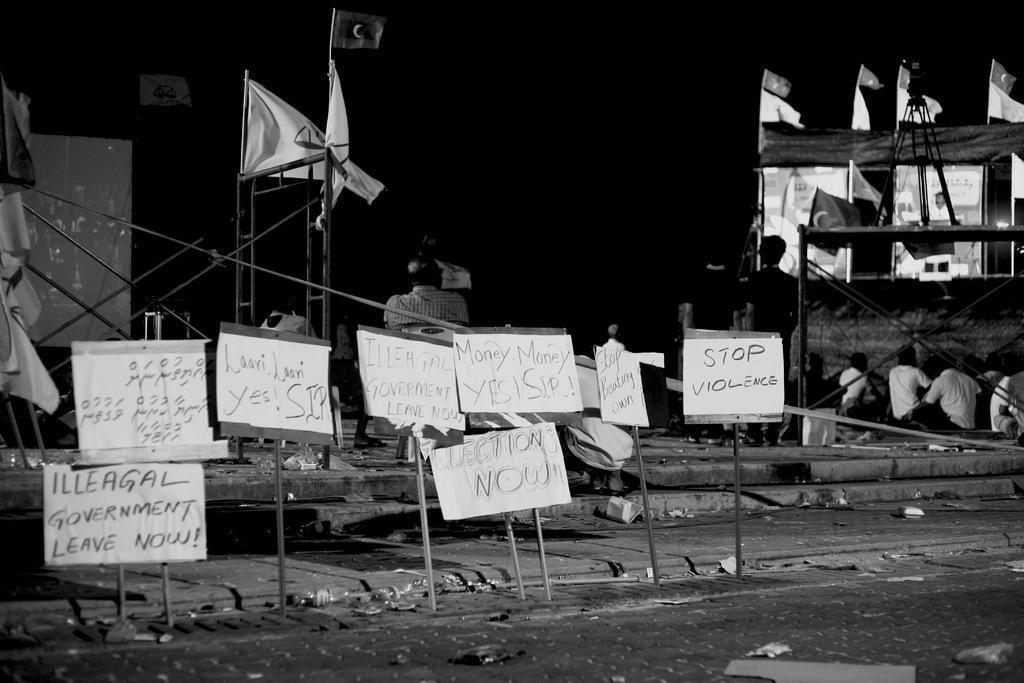Please provide a concise description of this image. In this image in the center there are boards with some text written on it. In the background there are flags and there are persons standing and sitting. 